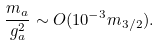<formula> <loc_0><loc_0><loc_500><loc_500>\frac { m _ { a } } { g _ { a } ^ { 2 } } \sim O ( 1 0 ^ { - 3 } m _ { 3 / 2 } ) .</formula> 